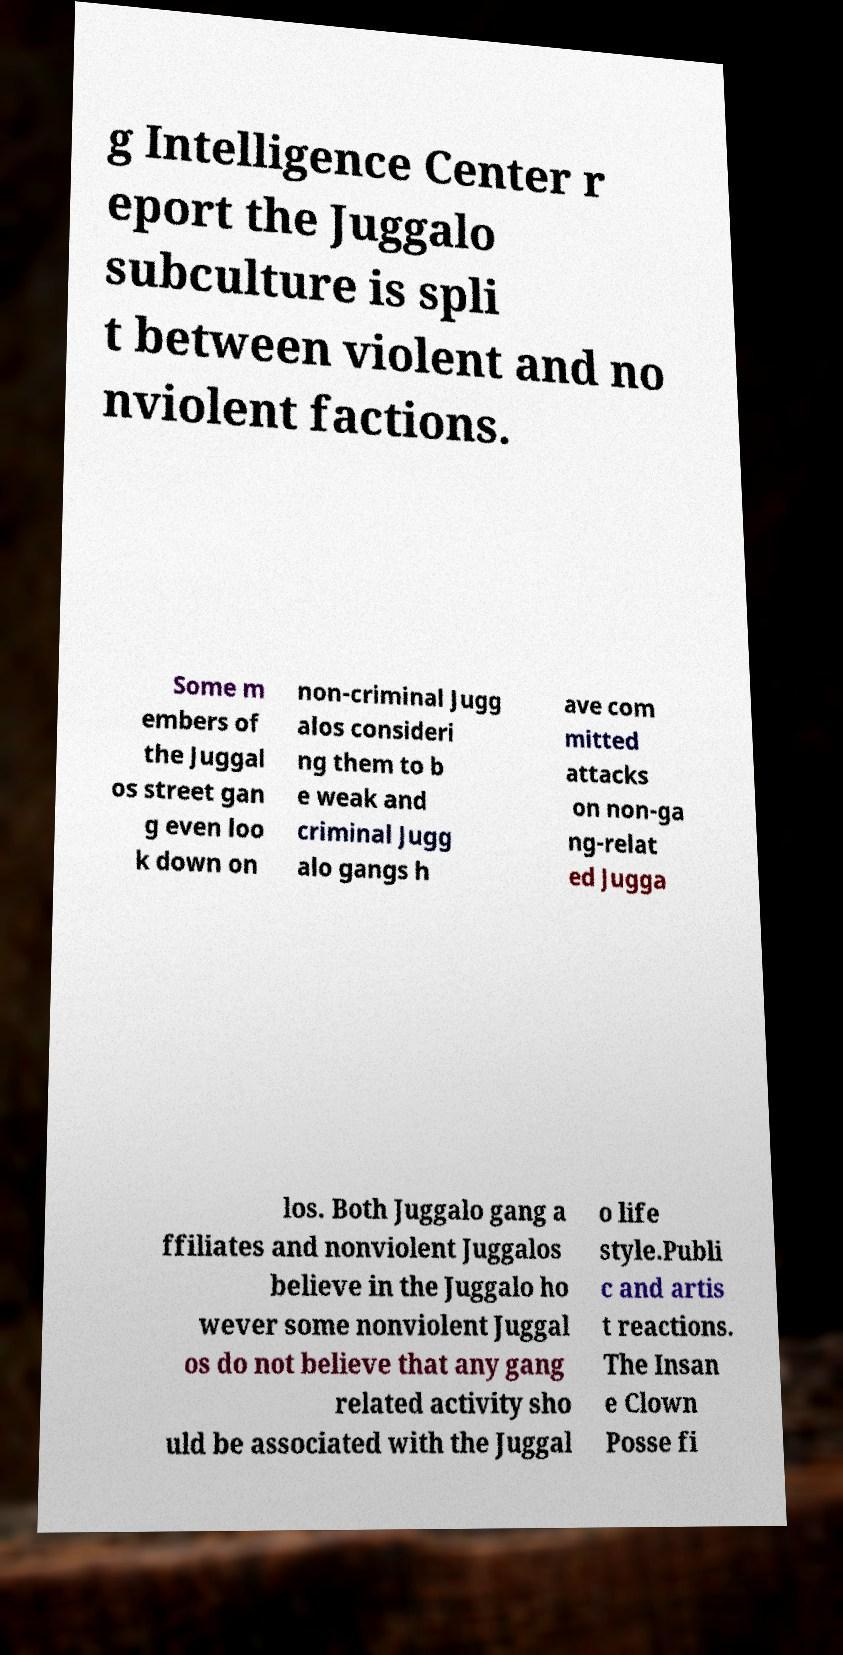Can you accurately transcribe the text from the provided image for me? g Intelligence Center r eport the Juggalo subculture is spli t between violent and no nviolent factions. Some m embers of the Juggal os street gan g even loo k down on non-criminal Jugg alos consideri ng them to b e weak and criminal Jugg alo gangs h ave com mitted attacks on non-ga ng-relat ed Jugga los. Both Juggalo gang a ffiliates and nonviolent Juggalos believe in the Juggalo ho wever some nonviolent Juggal os do not believe that any gang related activity sho uld be associated with the Juggal o life style.Publi c and artis t reactions. The Insan e Clown Posse fi 